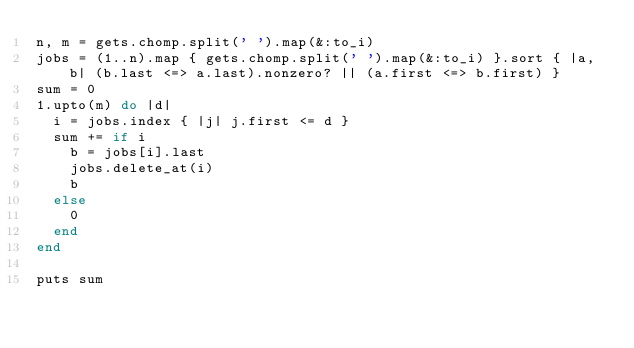<code> <loc_0><loc_0><loc_500><loc_500><_Ruby_>n, m = gets.chomp.split(' ').map(&:to_i)
jobs = (1..n).map { gets.chomp.split(' ').map(&:to_i) }.sort { |a, b| (b.last <=> a.last).nonzero? || (a.first <=> b.first) }
sum = 0
1.upto(m) do |d|
  i = jobs.index { |j| j.first <= d }
  sum += if i
    b = jobs[i].last
    jobs.delete_at(i)
    b
  else
    0
  end
end

puts sum
</code> 